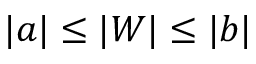Convert formula to latex. <formula><loc_0><loc_0><loc_500><loc_500>| a | \leq | W | \leq | b |</formula> 